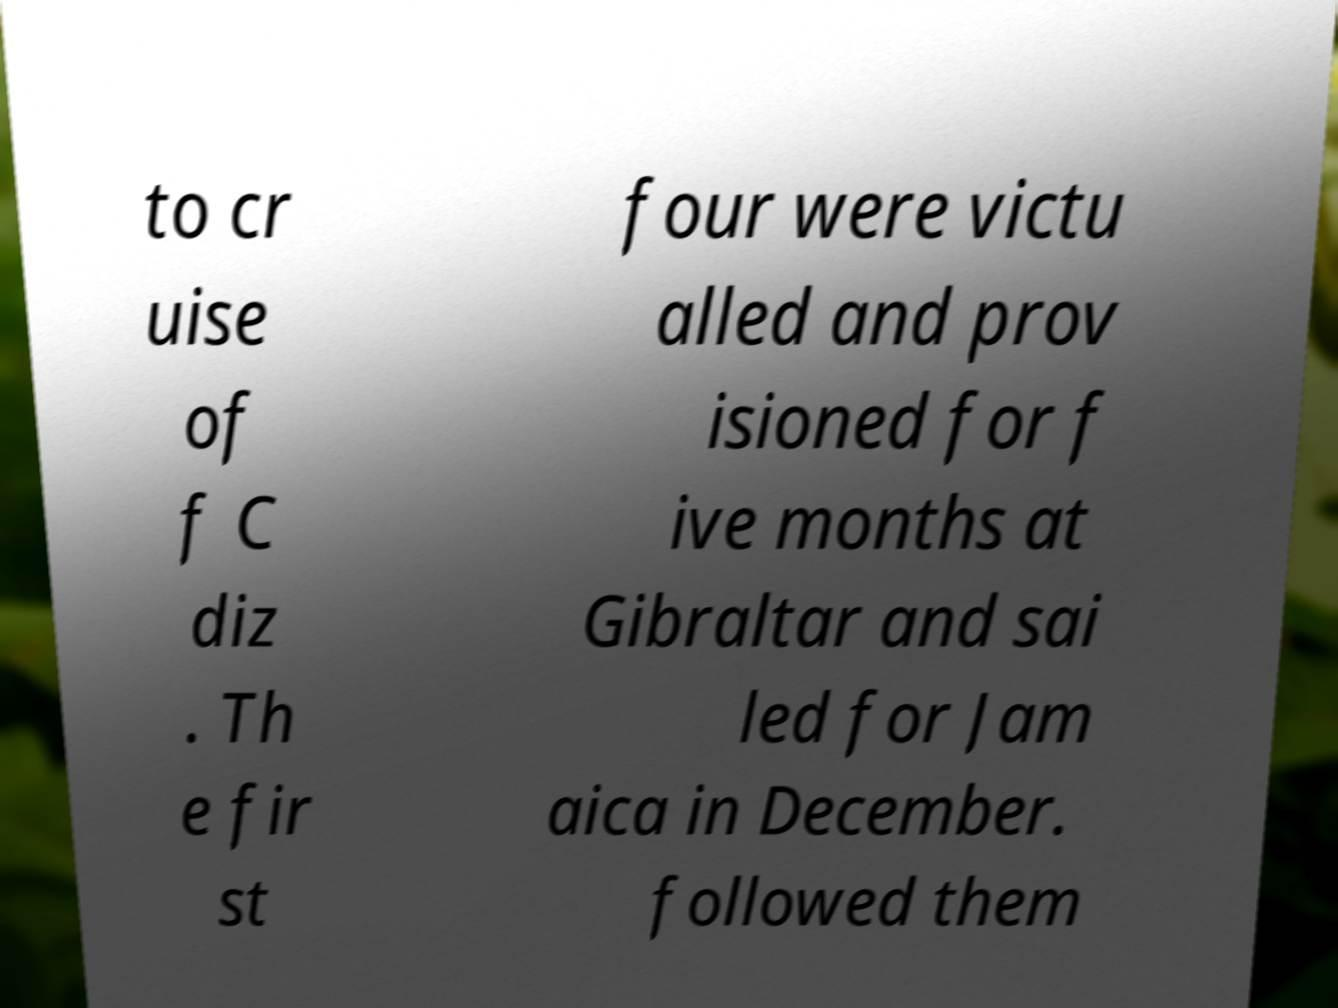Can you read and provide the text displayed in the image?This photo seems to have some interesting text. Can you extract and type it out for me? to cr uise of f C diz . Th e fir st four were victu alled and prov isioned for f ive months at Gibraltar and sai led for Jam aica in December. followed them 